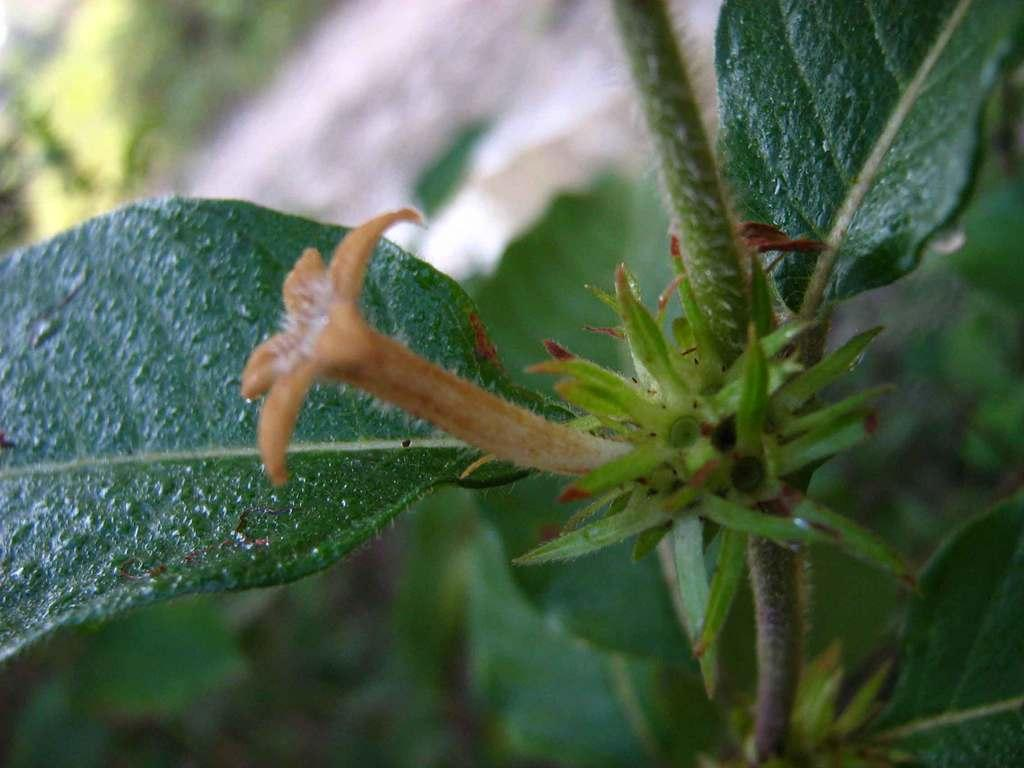What is present on the stem of a plant in the image? There is a flower on the stem of a plant in the image. What can be seen in the background of the image? There are plants visible in the background of the image. What type of rhythm does the flower follow in the image? The flower does not follow any rhythm in the image; it is a static object. 